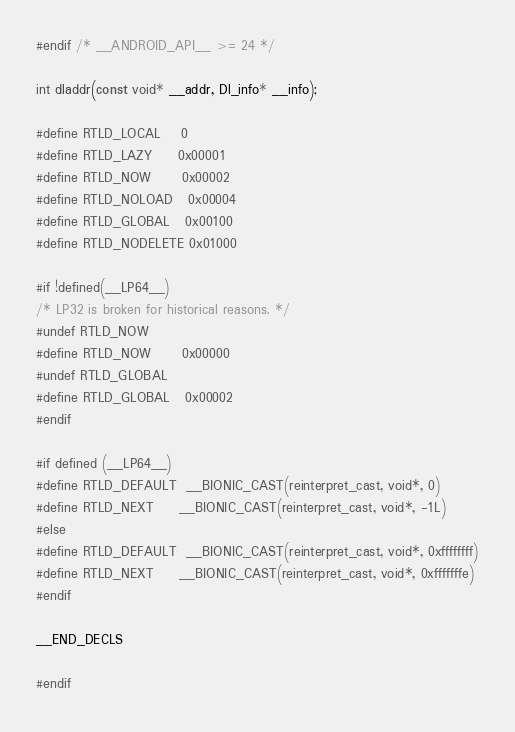Convert code to text. <code><loc_0><loc_0><loc_500><loc_500><_C_>#endif /* __ANDROID_API__ >= 24 */

int dladdr(const void* __addr, Dl_info* __info);

#define RTLD_LOCAL    0
#define RTLD_LAZY     0x00001
#define RTLD_NOW      0x00002
#define RTLD_NOLOAD   0x00004
#define RTLD_GLOBAL   0x00100
#define RTLD_NODELETE 0x01000

#if !defined(__LP64__)
/* LP32 is broken for historical reasons. */
#undef RTLD_NOW
#define RTLD_NOW      0x00000
#undef RTLD_GLOBAL
#define RTLD_GLOBAL   0x00002
#endif

#if defined (__LP64__)
#define RTLD_DEFAULT  __BIONIC_CAST(reinterpret_cast, void*, 0)
#define RTLD_NEXT     __BIONIC_CAST(reinterpret_cast, void*, -1L)
#else
#define RTLD_DEFAULT  __BIONIC_CAST(reinterpret_cast, void*, 0xffffffff)
#define RTLD_NEXT     __BIONIC_CAST(reinterpret_cast, void*, 0xfffffffe)
#endif

__END_DECLS

#endif
</code> 